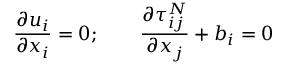Convert formula to latex. <formula><loc_0><loc_0><loc_500><loc_500>\frac { \partial u _ { i } } { \partial x _ { i } } = 0 ; \quad \frac { \partial \tau _ { i j } ^ { N } } { \partial x _ { j } } + b _ { i } = 0</formula> 